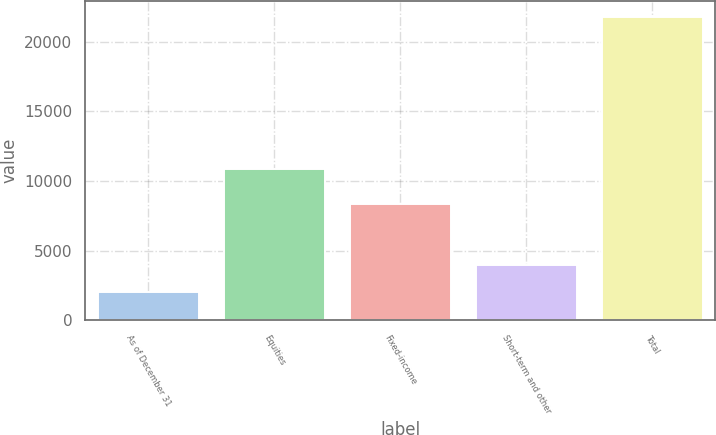Convert chart to OTSL. <chart><loc_0><loc_0><loc_500><loc_500><bar_chart><fcel>As of December 31<fcel>Equities<fcel>Fixed-income<fcel>Short-term and other<fcel>Total<nl><fcel>2011<fcel>10849<fcel>8317<fcel>3990.6<fcel>21807<nl></chart> 